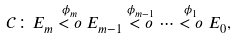Convert formula to latex. <formula><loc_0><loc_0><loc_500><loc_500>\mathcal { C } \colon E _ { m } \overset { \phi _ { m } } { < o } E _ { m - 1 } \overset { \phi _ { m - 1 } } { < o } \cdots \overset { \phi _ { 1 } } { < o } E _ { 0 } ,</formula> 